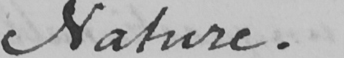What text is written in this handwritten line? Nature . 